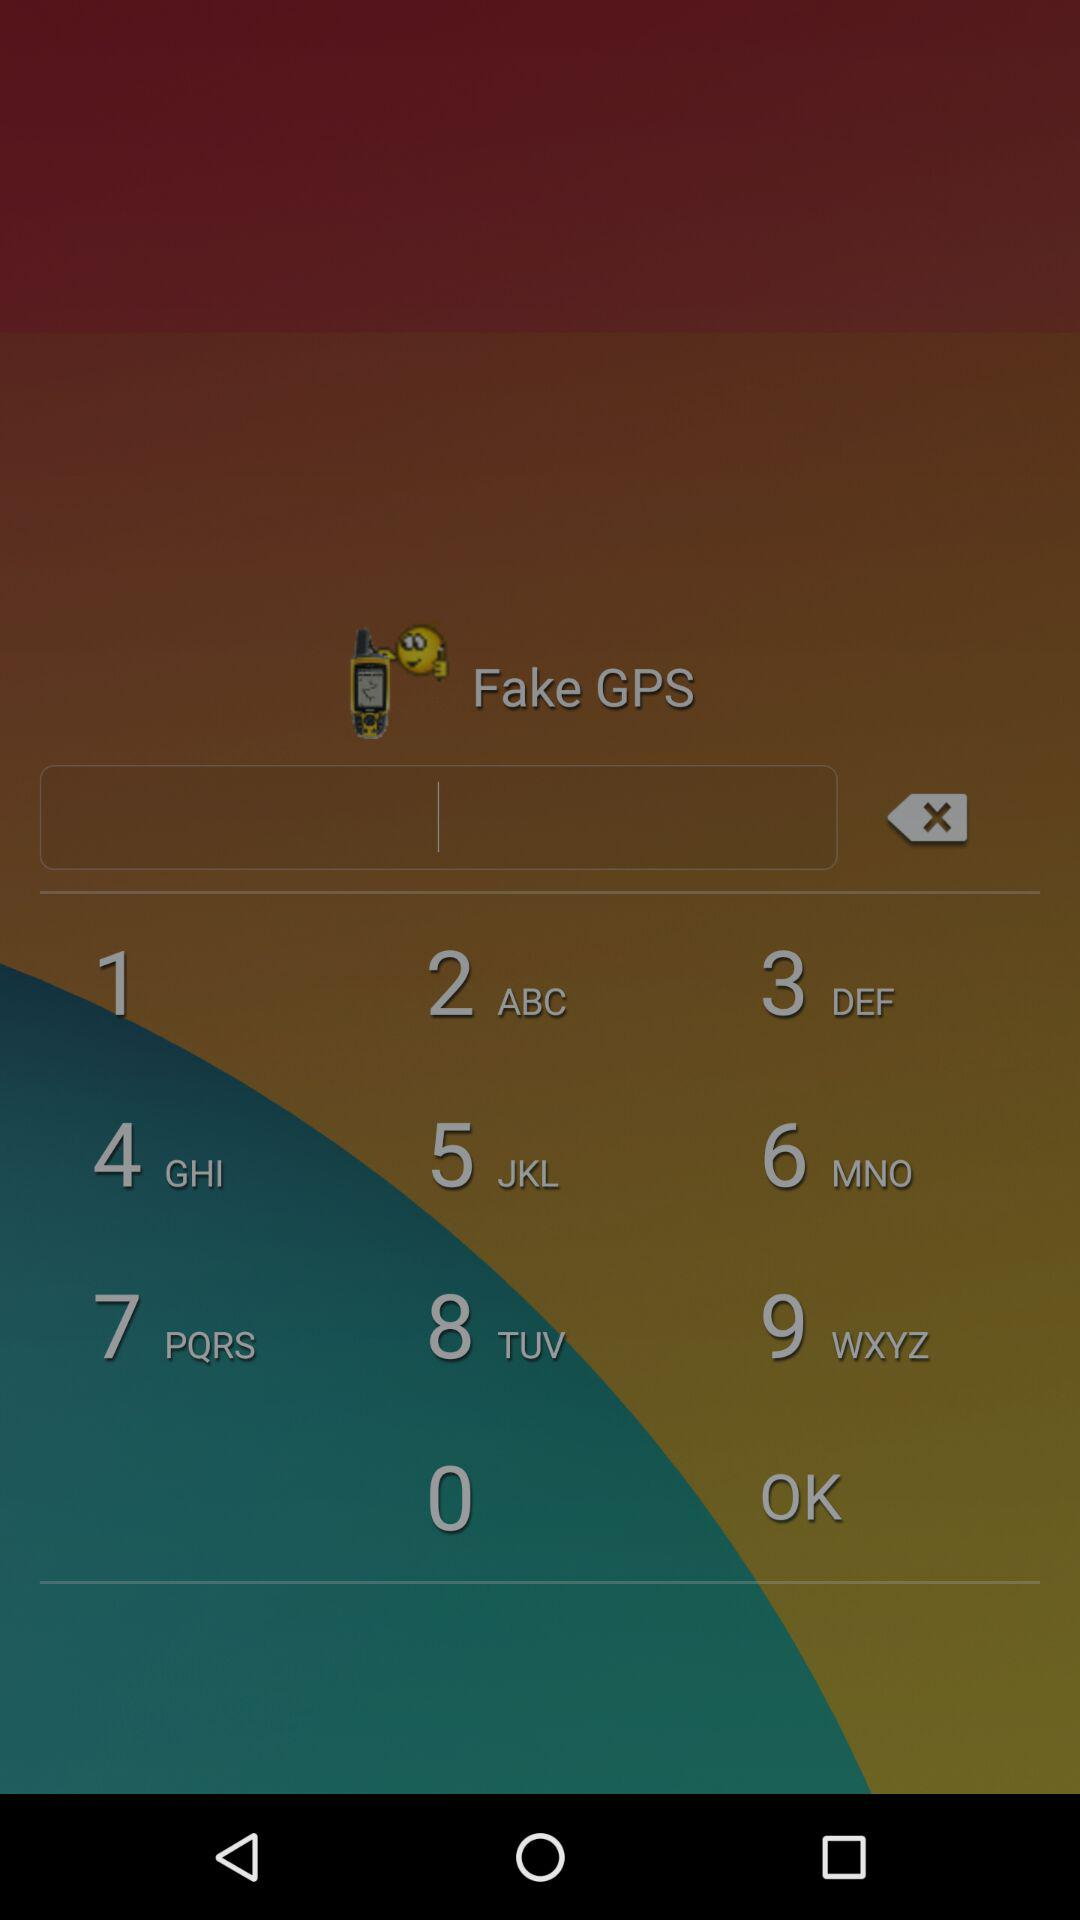What is the email ID of Sam? The email ID of Sam is sam1423825@aol.com. 